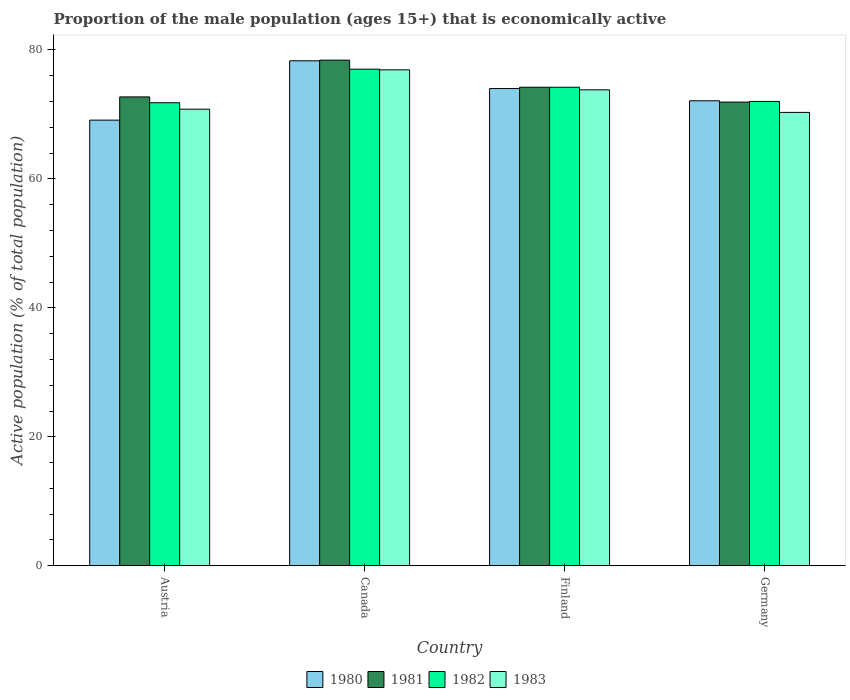How many different coloured bars are there?
Offer a very short reply. 4. Are the number of bars per tick equal to the number of legend labels?
Offer a very short reply. Yes. How many bars are there on the 3rd tick from the left?
Your answer should be very brief. 4. How many bars are there on the 4th tick from the right?
Keep it short and to the point. 4. What is the label of the 3rd group of bars from the left?
Ensure brevity in your answer.  Finland. In how many cases, is the number of bars for a given country not equal to the number of legend labels?
Ensure brevity in your answer.  0. What is the proportion of the male population that is economically active in 1981 in Germany?
Offer a very short reply. 71.9. Across all countries, what is the maximum proportion of the male population that is economically active in 1980?
Your response must be concise. 78.3. Across all countries, what is the minimum proportion of the male population that is economically active in 1983?
Offer a very short reply. 70.3. In which country was the proportion of the male population that is economically active in 1983 maximum?
Keep it short and to the point. Canada. In which country was the proportion of the male population that is economically active in 1981 minimum?
Make the answer very short. Germany. What is the total proportion of the male population that is economically active in 1980 in the graph?
Make the answer very short. 293.5. What is the difference between the proportion of the male population that is economically active in 1980 in Finland and that in Germany?
Make the answer very short. 1.9. What is the difference between the proportion of the male population that is economically active in 1980 in Canada and the proportion of the male population that is economically active in 1981 in Finland?
Keep it short and to the point. 4.1. What is the average proportion of the male population that is economically active in 1981 per country?
Make the answer very short. 74.3. What is the difference between the proportion of the male population that is economically active of/in 1980 and proportion of the male population that is economically active of/in 1982 in Germany?
Your answer should be very brief. 0.1. In how many countries, is the proportion of the male population that is economically active in 1982 greater than 36 %?
Ensure brevity in your answer.  4. What is the ratio of the proportion of the male population that is economically active in 1983 in Finland to that in Germany?
Ensure brevity in your answer.  1.05. Is the proportion of the male population that is economically active in 1983 in Canada less than that in Finland?
Make the answer very short. No. What is the difference between the highest and the second highest proportion of the male population that is economically active in 1981?
Keep it short and to the point. -1.5. What is the difference between the highest and the lowest proportion of the male population that is economically active in 1983?
Provide a short and direct response. 6.6. In how many countries, is the proportion of the male population that is economically active in 1980 greater than the average proportion of the male population that is economically active in 1980 taken over all countries?
Provide a short and direct response. 2. What does the 1st bar from the left in Germany represents?
Offer a very short reply. 1980. What does the 1st bar from the right in Germany represents?
Keep it short and to the point. 1983. How many bars are there?
Offer a terse response. 16. Are all the bars in the graph horizontal?
Your answer should be compact. No. How many countries are there in the graph?
Provide a succinct answer. 4. What is the difference between two consecutive major ticks on the Y-axis?
Your response must be concise. 20. How many legend labels are there?
Keep it short and to the point. 4. How are the legend labels stacked?
Give a very brief answer. Horizontal. What is the title of the graph?
Provide a short and direct response. Proportion of the male population (ages 15+) that is economically active. Does "1996" appear as one of the legend labels in the graph?
Make the answer very short. No. What is the label or title of the Y-axis?
Offer a terse response. Active population (% of total population). What is the Active population (% of total population) in 1980 in Austria?
Ensure brevity in your answer.  69.1. What is the Active population (% of total population) in 1981 in Austria?
Your response must be concise. 72.7. What is the Active population (% of total population) in 1982 in Austria?
Give a very brief answer. 71.8. What is the Active population (% of total population) of 1983 in Austria?
Give a very brief answer. 70.8. What is the Active population (% of total population) of 1980 in Canada?
Your answer should be compact. 78.3. What is the Active population (% of total population) in 1981 in Canada?
Keep it short and to the point. 78.4. What is the Active population (% of total population) of 1982 in Canada?
Provide a succinct answer. 77. What is the Active population (% of total population) of 1983 in Canada?
Keep it short and to the point. 76.9. What is the Active population (% of total population) in 1981 in Finland?
Provide a succinct answer. 74.2. What is the Active population (% of total population) of 1982 in Finland?
Offer a terse response. 74.2. What is the Active population (% of total population) of 1983 in Finland?
Ensure brevity in your answer.  73.8. What is the Active population (% of total population) of 1980 in Germany?
Keep it short and to the point. 72.1. What is the Active population (% of total population) in 1981 in Germany?
Provide a short and direct response. 71.9. What is the Active population (% of total population) in 1982 in Germany?
Ensure brevity in your answer.  72. What is the Active population (% of total population) of 1983 in Germany?
Keep it short and to the point. 70.3. Across all countries, what is the maximum Active population (% of total population) of 1980?
Give a very brief answer. 78.3. Across all countries, what is the maximum Active population (% of total population) in 1981?
Provide a short and direct response. 78.4. Across all countries, what is the maximum Active population (% of total population) of 1982?
Your answer should be very brief. 77. Across all countries, what is the maximum Active population (% of total population) in 1983?
Your answer should be very brief. 76.9. Across all countries, what is the minimum Active population (% of total population) of 1980?
Offer a terse response. 69.1. Across all countries, what is the minimum Active population (% of total population) of 1981?
Give a very brief answer. 71.9. Across all countries, what is the minimum Active population (% of total population) in 1982?
Keep it short and to the point. 71.8. Across all countries, what is the minimum Active population (% of total population) in 1983?
Offer a very short reply. 70.3. What is the total Active population (% of total population) of 1980 in the graph?
Ensure brevity in your answer.  293.5. What is the total Active population (% of total population) of 1981 in the graph?
Make the answer very short. 297.2. What is the total Active population (% of total population) in 1982 in the graph?
Your response must be concise. 295. What is the total Active population (% of total population) of 1983 in the graph?
Make the answer very short. 291.8. What is the difference between the Active population (% of total population) in 1980 in Austria and that in Canada?
Give a very brief answer. -9.2. What is the difference between the Active population (% of total population) in 1981 in Austria and that in Canada?
Ensure brevity in your answer.  -5.7. What is the difference between the Active population (% of total population) of 1983 in Austria and that in Canada?
Offer a very short reply. -6.1. What is the difference between the Active population (% of total population) of 1980 in Austria and that in Finland?
Your answer should be very brief. -4.9. What is the difference between the Active population (% of total population) in 1980 in Austria and that in Germany?
Your response must be concise. -3. What is the difference between the Active population (% of total population) in 1981 in Austria and that in Germany?
Make the answer very short. 0.8. What is the difference between the Active population (% of total population) in 1982 in Canada and that in Finland?
Offer a very short reply. 2.8. What is the difference between the Active population (% of total population) of 1980 in Canada and that in Germany?
Make the answer very short. 6.2. What is the difference between the Active population (% of total population) in 1981 in Canada and that in Germany?
Make the answer very short. 6.5. What is the difference between the Active population (% of total population) in 1980 in Austria and the Active population (% of total population) in 1981 in Canada?
Give a very brief answer. -9.3. What is the difference between the Active population (% of total population) of 1980 in Austria and the Active population (% of total population) of 1982 in Canada?
Keep it short and to the point. -7.9. What is the difference between the Active population (% of total population) of 1981 in Austria and the Active population (% of total population) of 1983 in Canada?
Your answer should be compact. -4.2. What is the difference between the Active population (% of total population) in 1980 in Austria and the Active population (% of total population) in 1981 in Finland?
Provide a short and direct response. -5.1. What is the difference between the Active population (% of total population) in 1980 in Austria and the Active population (% of total population) in 1982 in Finland?
Offer a very short reply. -5.1. What is the difference between the Active population (% of total population) in 1982 in Austria and the Active population (% of total population) in 1983 in Finland?
Make the answer very short. -2. What is the difference between the Active population (% of total population) of 1980 in Austria and the Active population (% of total population) of 1981 in Germany?
Give a very brief answer. -2.8. What is the difference between the Active population (% of total population) of 1980 in Austria and the Active population (% of total population) of 1982 in Germany?
Offer a terse response. -2.9. What is the difference between the Active population (% of total population) in 1980 in Austria and the Active population (% of total population) in 1983 in Germany?
Make the answer very short. -1.2. What is the difference between the Active population (% of total population) of 1981 in Austria and the Active population (% of total population) of 1983 in Germany?
Provide a short and direct response. 2.4. What is the difference between the Active population (% of total population) of 1982 in Austria and the Active population (% of total population) of 1983 in Germany?
Keep it short and to the point. 1.5. What is the difference between the Active population (% of total population) in 1980 in Canada and the Active population (% of total population) in 1981 in Finland?
Offer a very short reply. 4.1. What is the difference between the Active population (% of total population) in 1980 in Canada and the Active population (% of total population) in 1982 in Finland?
Your answer should be compact. 4.1. What is the difference between the Active population (% of total population) of 1980 in Canada and the Active population (% of total population) of 1983 in Finland?
Keep it short and to the point. 4.5. What is the difference between the Active population (% of total population) in 1981 in Canada and the Active population (% of total population) in 1982 in Finland?
Make the answer very short. 4.2. What is the difference between the Active population (% of total population) of 1981 in Canada and the Active population (% of total population) of 1983 in Finland?
Make the answer very short. 4.6. What is the difference between the Active population (% of total population) of 1981 in Canada and the Active population (% of total population) of 1983 in Germany?
Your answer should be compact. 8.1. What is the difference between the Active population (% of total population) of 1980 in Finland and the Active population (% of total population) of 1983 in Germany?
Give a very brief answer. 3.7. What is the difference between the Active population (% of total population) in 1981 in Finland and the Active population (% of total population) in 1982 in Germany?
Provide a succinct answer. 2.2. What is the difference between the Active population (% of total population) of 1981 in Finland and the Active population (% of total population) of 1983 in Germany?
Your answer should be compact. 3.9. What is the average Active population (% of total population) of 1980 per country?
Your answer should be compact. 73.38. What is the average Active population (% of total population) in 1981 per country?
Ensure brevity in your answer.  74.3. What is the average Active population (% of total population) of 1982 per country?
Provide a short and direct response. 73.75. What is the average Active population (% of total population) of 1983 per country?
Your answer should be compact. 72.95. What is the difference between the Active population (% of total population) of 1980 and Active population (% of total population) of 1982 in Austria?
Give a very brief answer. -2.7. What is the difference between the Active population (% of total population) of 1980 and Active population (% of total population) of 1983 in Austria?
Offer a terse response. -1.7. What is the difference between the Active population (% of total population) of 1981 and Active population (% of total population) of 1983 in Austria?
Ensure brevity in your answer.  1.9. What is the difference between the Active population (% of total population) in 1982 and Active population (% of total population) in 1983 in Austria?
Provide a short and direct response. 1. What is the difference between the Active population (% of total population) in 1980 and Active population (% of total population) in 1981 in Canada?
Offer a terse response. -0.1. What is the difference between the Active population (% of total population) in 1980 and Active population (% of total population) in 1982 in Canada?
Keep it short and to the point. 1.3. What is the difference between the Active population (% of total population) of 1980 and Active population (% of total population) of 1983 in Canada?
Keep it short and to the point. 1.4. What is the difference between the Active population (% of total population) in 1980 and Active population (% of total population) in 1981 in Finland?
Keep it short and to the point. -0.2. What is the difference between the Active population (% of total population) in 1980 and Active population (% of total population) in 1982 in Finland?
Your answer should be very brief. -0.2. What is the difference between the Active population (% of total population) in 1980 and Active population (% of total population) in 1983 in Finland?
Give a very brief answer. 0.2. What is the difference between the Active population (% of total population) in 1981 and Active population (% of total population) in 1982 in Finland?
Ensure brevity in your answer.  0. What is the difference between the Active population (% of total population) of 1981 and Active population (% of total population) of 1983 in Finland?
Provide a short and direct response. 0.4. What is the difference between the Active population (% of total population) in 1982 and Active population (% of total population) in 1983 in Finland?
Your answer should be very brief. 0.4. What is the difference between the Active population (% of total population) of 1980 and Active population (% of total population) of 1981 in Germany?
Keep it short and to the point. 0.2. What is the difference between the Active population (% of total population) in 1980 and Active population (% of total population) in 1982 in Germany?
Your answer should be very brief. 0.1. What is the difference between the Active population (% of total population) of 1980 and Active population (% of total population) of 1983 in Germany?
Make the answer very short. 1.8. What is the difference between the Active population (% of total population) in 1981 and Active population (% of total population) in 1983 in Germany?
Your answer should be very brief. 1.6. What is the ratio of the Active population (% of total population) in 1980 in Austria to that in Canada?
Offer a terse response. 0.88. What is the ratio of the Active population (% of total population) of 1981 in Austria to that in Canada?
Ensure brevity in your answer.  0.93. What is the ratio of the Active population (% of total population) of 1982 in Austria to that in Canada?
Provide a short and direct response. 0.93. What is the ratio of the Active population (% of total population) of 1983 in Austria to that in Canada?
Your response must be concise. 0.92. What is the ratio of the Active population (% of total population) in 1980 in Austria to that in Finland?
Make the answer very short. 0.93. What is the ratio of the Active population (% of total population) in 1981 in Austria to that in Finland?
Provide a short and direct response. 0.98. What is the ratio of the Active population (% of total population) in 1982 in Austria to that in Finland?
Give a very brief answer. 0.97. What is the ratio of the Active population (% of total population) of 1983 in Austria to that in Finland?
Give a very brief answer. 0.96. What is the ratio of the Active population (% of total population) in 1980 in Austria to that in Germany?
Your answer should be very brief. 0.96. What is the ratio of the Active population (% of total population) in 1981 in Austria to that in Germany?
Ensure brevity in your answer.  1.01. What is the ratio of the Active population (% of total population) of 1982 in Austria to that in Germany?
Ensure brevity in your answer.  1. What is the ratio of the Active population (% of total population) of 1983 in Austria to that in Germany?
Ensure brevity in your answer.  1.01. What is the ratio of the Active population (% of total population) in 1980 in Canada to that in Finland?
Provide a succinct answer. 1.06. What is the ratio of the Active population (% of total population) in 1981 in Canada to that in Finland?
Offer a very short reply. 1.06. What is the ratio of the Active population (% of total population) of 1982 in Canada to that in Finland?
Your answer should be compact. 1.04. What is the ratio of the Active population (% of total population) in 1983 in Canada to that in Finland?
Keep it short and to the point. 1.04. What is the ratio of the Active population (% of total population) of 1980 in Canada to that in Germany?
Offer a very short reply. 1.09. What is the ratio of the Active population (% of total population) in 1981 in Canada to that in Germany?
Your response must be concise. 1.09. What is the ratio of the Active population (% of total population) in 1982 in Canada to that in Germany?
Make the answer very short. 1.07. What is the ratio of the Active population (% of total population) in 1983 in Canada to that in Germany?
Ensure brevity in your answer.  1.09. What is the ratio of the Active population (% of total population) in 1980 in Finland to that in Germany?
Provide a succinct answer. 1.03. What is the ratio of the Active population (% of total population) of 1981 in Finland to that in Germany?
Keep it short and to the point. 1.03. What is the ratio of the Active population (% of total population) of 1982 in Finland to that in Germany?
Offer a very short reply. 1.03. What is the ratio of the Active population (% of total population) of 1983 in Finland to that in Germany?
Make the answer very short. 1.05. What is the difference between the highest and the second highest Active population (% of total population) in 1981?
Keep it short and to the point. 4.2. What is the difference between the highest and the lowest Active population (% of total population) in 1981?
Your answer should be compact. 6.5. 